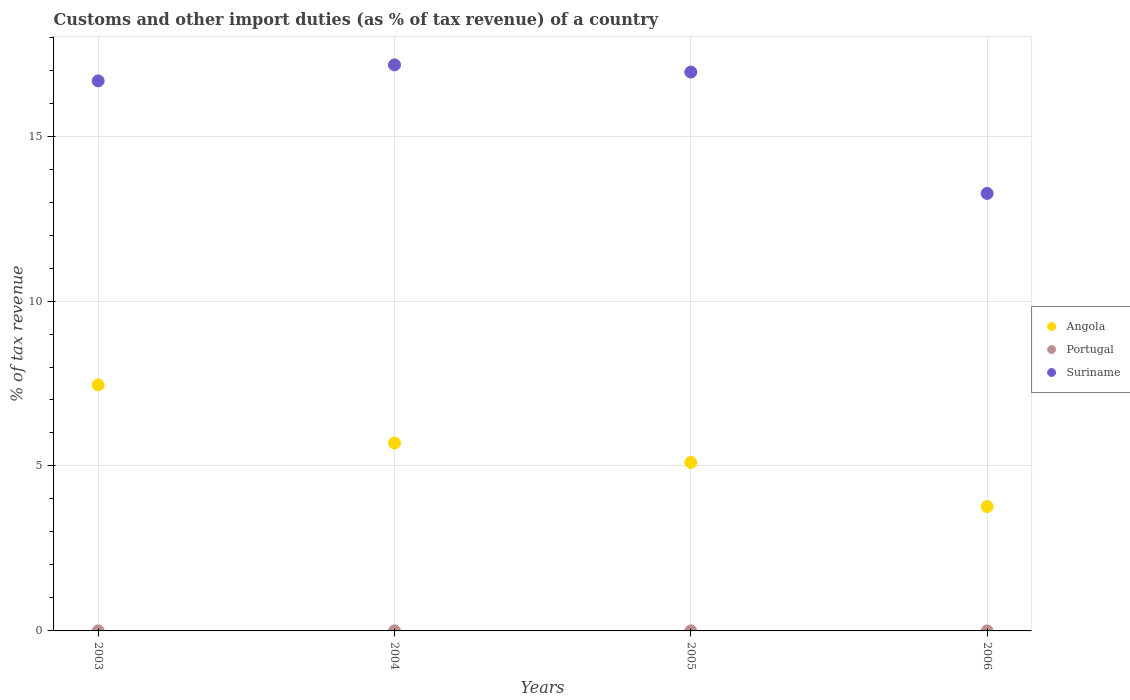What is the percentage of tax revenue from customs in Suriname in 2003?
Your answer should be compact. 16.67. Across all years, what is the maximum percentage of tax revenue from customs in Portugal?
Make the answer very short. 0. Across all years, what is the minimum percentage of tax revenue from customs in Portugal?
Keep it short and to the point. 0. What is the total percentage of tax revenue from customs in Suriname in the graph?
Your answer should be very brief. 64.03. What is the difference between the percentage of tax revenue from customs in Angola in 2005 and that in 2006?
Make the answer very short. 1.34. What is the difference between the percentage of tax revenue from customs in Portugal in 2004 and the percentage of tax revenue from customs in Suriname in 2005?
Provide a succinct answer. -16.94. What is the average percentage of tax revenue from customs in Portugal per year?
Give a very brief answer. 0. In the year 2006, what is the difference between the percentage of tax revenue from customs in Suriname and percentage of tax revenue from customs in Angola?
Keep it short and to the point. 9.49. What is the ratio of the percentage of tax revenue from customs in Suriname in 2003 to that in 2004?
Give a very brief answer. 0.97. What is the difference between the highest and the second highest percentage of tax revenue from customs in Angola?
Give a very brief answer. 1.76. What is the difference between the highest and the lowest percentage of tax revenue from customs in Suriname?
Your answer should be compact. 3.9. In how many years, is the percentage of tax revenue from customs in Suriname greater than the average percentage of tax revenue from customs in Suriname taken over all years?
Your answer should be compact. 3. Is the sum of the percentage of tax revenue from customs in Angola in 2005 and 2006 greater than the maximum percentage of tax revenue from customs in Suriname across all years?
Make the answer very short. No. Does the percentage of tax revenue from customs in Suriname monotonically increase over the years?
Provide a succinct answer. No. What is the difference between two consecutive major ticks on the Y-axis?
Offer a terse response. 5. Are the values on the major ticks of Y-axis written in scientific E-notation?
Your answer should be compact. No. Does the graph contain any zero values?
Provide a short and direct response. No. Does the graph contain grids?
Make the answer very short. Yes. How are the legend labels stacked?
Give a very brief answer. Vertical. What is the title of the graph?
Your answer should be compact. Customs and other import duties (as % of tax revenue) of a country. What is the label or title of the X-axis?
Offer a terse response. Years. What is the label or title of the Y-axis?
Provide a succinct answer. % of tax revenue. What is the % of tax revenue of Angola in 2003?
Your answer should be compact. 7.46. What is the % of tax revenue in Portugal in 2003?
Keep it short and to the point. 0. What is the % of tax revenue in Suriname in 2003?
Provide a short and direct response. 16.67. What is the % of tax revenue in Angola in 2004?
Your answer should be compact. 5.7. What is the % of tax revenue of Portugal in 2004?
Provide a short and direct response. 0. What is the % of tax revenue in Suriname in 2004?
Provide a succinct answer. 17.16. What is the % of tax revenue of Angola in 2005?
Provide a short and direct response. 5.11. What is the % of tax revenue of Portugal in 2005?
Offer a very short reply. 0. What is the % of tax revenue of Suriname in 2005?
Provide a succinct answer. 16.94. What is the % of tax revenue of Angola in 2006?
Provide a short and direct response. 3.77. What is the % of tax revenue in Portugal in 2006?
Offer a very short reply. 0. What is the % of tax revenue in Suriname in 2006?
Your answer should be very brief. 13.26. Across all years, what is the maximum % of tax revenue in Angola?
Offer a terse response. 7.46. Across all years, what is the maximum % of tax revenue in Portugal?
Give a very brief answer. 0. Across all years, what is the maximum % of tax revenue of Suriname?
Give a very brief answer. 17.16. Across all years, what is the minimum % of tax revenue in Angola?
Your response must be concise. 3.77. Across all years, what is the minimum % of tax revenue in Portugal?
Your answer should be very brief. 0. Across all years, what is the minimum % of tax revenue in Suriname?
Ensure brevity in your answer.  13.26. What is the total % of tax revenue in Angola in the graph?
Ensure brevity in your answer.  22.03. What is the total % of tax revenue in Portugal in the graph?
Make the answer very short. 0.01. What is the total % of tax revenue of Suriname in the graph?
Provide a short and direct response. 64.03. What is the difference between the % of tax revenue in Angola in 2003 and that in 2004?
Provide a short and direct response. 1.76. What is the difference between the % of tax revenue of Suriname in 2003 and that in 2004?
Make the answer very short. -0.48. What is the difference between the % of tax revenue of Angola in 2003 and that in 2005?
Your answer should be very brief. 2.35. What is the difference between the % of tax revenue of Suriname in 2003 and that in 2005?
Your response must be concise. -0.27. What is the difference between the % of tax revenue in Angola in 2003 and that in 2006?
Your answer should be compact. 3.69. What is the difference between the % of tax revenue in Portugal in 2003 and that in 2006?
Keep it short and to the point. 0. What is the difference between the % of tax revenue of Suriname in 2003 and that in 2006?
Your answer should be very brief. 3.41. What is the difference between the % of tax revenue of Angola in 2004 and that in 2005?
Your answer should be very brief. 0.59. What is the difference between the % of tax revenue of Portugal in 2004 and that in 2005?
Keep it short and to the point. 0. What is the difference between the % of tax revenue of Suriname in 2004 and that in 2005?
Give a very brief answer. 0.22. What is the difference between the % of tax revenue of Angola in 2004 and that in 2006?
Provide a succinct answer. 1.93. What is the difference between the % of tax revenue of Portugal in 2004 and that in 2006?
Provide a short and direct response. 0. What is the difference between the % of tax revenue of Suriname in 2004 and that in 2006?
Keep it short and to the point. 3.9. What is the difference between the % of tax revenue in Angola in 2005 and that in 2006?
Offer a terse response. 1.34. What is the difference between the % of tax revenue in Suriname in 2005 and that in 2006?
Offer a terse response. 3.68. What is the difference between the % of tax revenue of Angola in 2003 and the % of tax revenue of Portugal in 2004?
Keep it short and to the point. 7.46. What is the difference between the % of tax revenue in Angola in 2003 and the % of tax revenue in Suriname in 2004?
Your answer should be very brief. -9.7. What is the difference between the % of tax revenue of Portugal in 2003 and the % of tax revenue of Suriname in 2004?
Your response must be concise. -17.16. What is the difference between the % of tax revenue in Angola in 2003 and the % of tax revenue in Portugal in 2005?
Your answer should be compact. 7.46. What is the difference between the % of tax revenue of Angola in 2003 and the % of tax revenue of Suriname in 2005?
Keep it short and to the point. -9.48. What is the difference between the % of tax revenue of Portugal in 2003 and the % of tax revenue of Suriname in 2005?
Make the answer very short. -16.94. What is the difference between the % of tax revenue of Angola in 2003 and the % of tax revenue of Portugal in 2006?
Offer a terse response. 7.46. What is the difference between the % of tax revenue in Angola in 2003 and the % of tax revenue in Suriname in 2006?
Keep it short and to the point. -5.8. What is the difference between the % of tax revenue in Portugal in 2003 and the % of tax revenue in Suriname in 2006?
Your answer should be very brief. -13.26. What is the difference between the % of tax revenue of Angola in 2004 and the % of tax revenue of Portugal in 2005?
Provide a succinct answer. 5.7. What is the difference between the % of tax revenue in Angola in 2004 and the % of tax revenue in Suriname in 2005?
Keep it short and to the point. -11.24. What is the difference between the % of tax revenue in Portugal in 2004 and the % of tax revenue in Suriname in 2005?
Offer a terse response. -16.94. What is the difference between the % of tax revenue in Angola in 2004 and the % of tax revenue in Portugal in 2006?
Your answer should be compact. 5.7. What is the difference between the % of tax revenue in Angola in 2004 and the % of tax revenue in Suriname in 2006?
Provide a short and direct response. -7.56. What is the difference between the % of tax revenue of Portugal in 2004 and the % of tax revenue of Suriname in 2006?
Your response must be concise. -13.26. What is the difference between the % of tax revenue of Angola in 2005 and the % of tax revenue of Portugal in 2006?
Keep it short and to the point. 5.1. What is the difference between the % of tax revenue of Angola in 2005 and the % of tax revenue of Suriname in 2006?
Give a very brief answer. -8.16. What is the difference between the % of tax revenue of Portugal in 2005 and the % of tax revenue of Suriname in 2006?
Give a very brief answer. -13.26. What is the average % of tax revenue in Angola per year?
Ensure brevity in your answer.  5.51. What is the average % of tax revenue in Portugal per year?
Make the answer very short. 0. What is the average % of tax revenue in Suriname per year?
Ensure brevity in your answer.  16.01. In the year 2003, what is the difference between the % of tax revenue in Angola and % of tax revenue in Portugal?
Your answer should be compact. 7.46. In the year 2003, what is the difference between the % of tax revenue in Angola and % of tax revenue in Suriname?
Provide a short and direct response. -9.22. In the year 2003, what is the difference between the % of tax revenue in Portugal and % of tax revenue in Suriname?
Offer a very short reply. -16.67. In the year 2004, what is the difference between the % of tax revenue in Angola and % of tax revenue in Portugal?
Provide a succinct answer. 5.7. In the year 2004, what is the difference between the % of tax revenue of Angola and % of tax revenue of Suriname?
Ensure brevity in your answer.  -11.46. In the year 2004, what is the difference between the % of tax revenue of Portugal and % of tax revenue of Suriname?
Keep it short and to the point. -17.16. In the year 2005, what is the difference between the % of tax revenue of Angola and % of tax revenue of Portugal?
Give a very brief answer. 5.1. In the year 2005, what is the difference between the % of tax revenue of Angola and % of tax revenue of Suriname?
Offer a very short reply. -11.83. In the year 2005, what is the difference between the % of tax revenue in Portugal and % of tax revenue in Suriname?
Offer a terse response. -16.94. In the year 2006, what is the difference between the % of tax revenue in Angola and % of tax revenue in Portugal?
Give a very brief answer. 3.77. In the year 2006, what is the difference between the % of tax revenue of Angola and % of tax revenue of Suriname?
Ensure brevity in your answer.  -9.49. In the year 2006, what is the difference between the % of tax revenue of Portugal and % of tax revenue of Suriname?
Your answer should be very brief. -13.26. What is the ratio of the % of tax revenue of Angola in 2003 to that in 2004?
Provide a succinct answer. 1.31. What is the ratio of the % of tax revenue in Portugal in 2003 to that in 2004?
Keep it short and to the point. 0.97. What is the ratio of the % of tax revenue of Suriname in 2003 to that in 2004?
Offer a terse response. 0.97. What is the ratio of the % of tax revenue of Angola in 2003 to that in 2005?
Provide a short and direct response. 1.46. What is the ratio of the % of tax revenue of Portugal in 2003 to that in 2005?
Ensure brevity in your answer.  1.07. What is the ratio of the % of tax revenue of Suriname in 2003 to that in 2005?
Provide a short and direct response. 0.98. What is the ratio of the % of tax revenue in Angola in 2003 to that in 2006?
Your response must be concise. 1.98. What is the ratio of the % of tax revenue in Portugal in 2003 to that in 2006?
Offer a very short reply. 1.1. What is the ratio of the % of tax revenue of Suriname in 2003 to that in 2006?
Provide a succinct answer. 1.26. What is the ratio of the % of tax revenue of Angola in 2004 to that in 2005?
Make the answer very short. 1.12. What is the ratio of the % of tax revenue in Portugal in 2004 to that in 2005?
Your answer should be compact. 1.1. What is the ratio of the % of tax revenue of Suriname in 2004 to that in 2005?
Your answer should be very brief. 1.01. What is the ratio of the % of tax revenue in Angola in 2004 to that in 2006?
Provide a short and direct response. 1.51. What is the ratio of the % of tax revenue in Portugal in 2004 to that in 2006?
Give a very brief answer. 1.13. What is the ratio of the % of tax revenue of Suriname in 2004 to that in 2006?
Provide a short and direct response. 1.29. What is the ratio of the % of tax revenue in Angola in 2005 to that in 2006?
Provide a succinct answer. 1.35. What is the ratio of the % of tax revenue in Portugal in 2005 to that in 2006?
Your answer should be compact. 1.03. What is the ratio of the % of tax revenue of Suriname in 2005 to that in 2006?
Provide a short and direct response. 1.28. What is the difference between the highest and the second highest % of tax revenue of Angola?
Offer a very short reply. 1.76. What is the difference between the highest and the second highest % of tax revenue in Portugal?
Provide a short and direct response. 0. What is the difference between the highest and the second highest % of tax revenue of Suriname?
Provide a short and direct response. 0.22. What is the difference between the highest and the lowest % of tax revenue of Angola?
Your answer should be compact. 3.69. What is the difference between the highest and the lowest % of tax revenue of Suriname?
Ensure brevity in your answer.  3.9. 